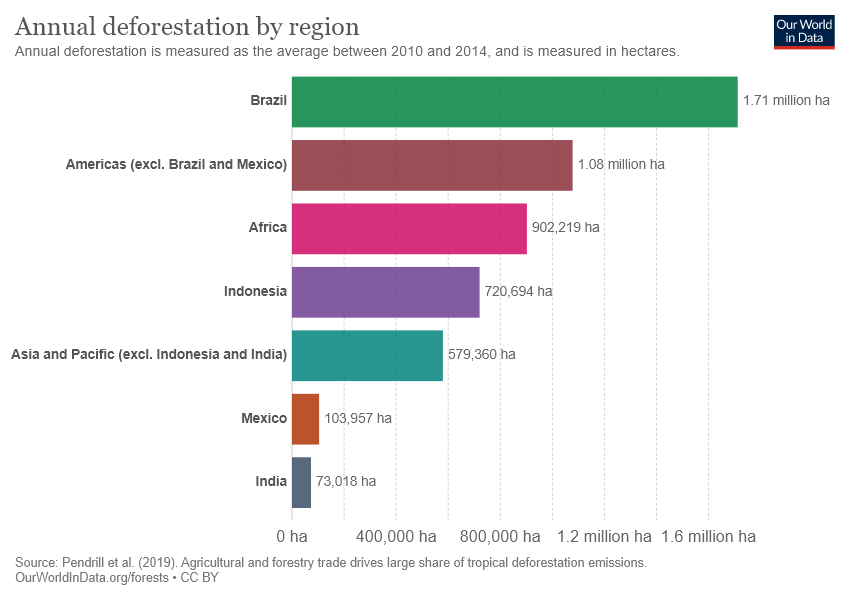Give some essential details in this illustration. India has the smallest bar. The average of India, Mexico, and Indonesia is not greater than the value of Asia and Pacific. 